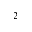Convert formula to latex. <formula><loc_0><loc_0><loc_500><loc_500>_ { 2 }</formula> 